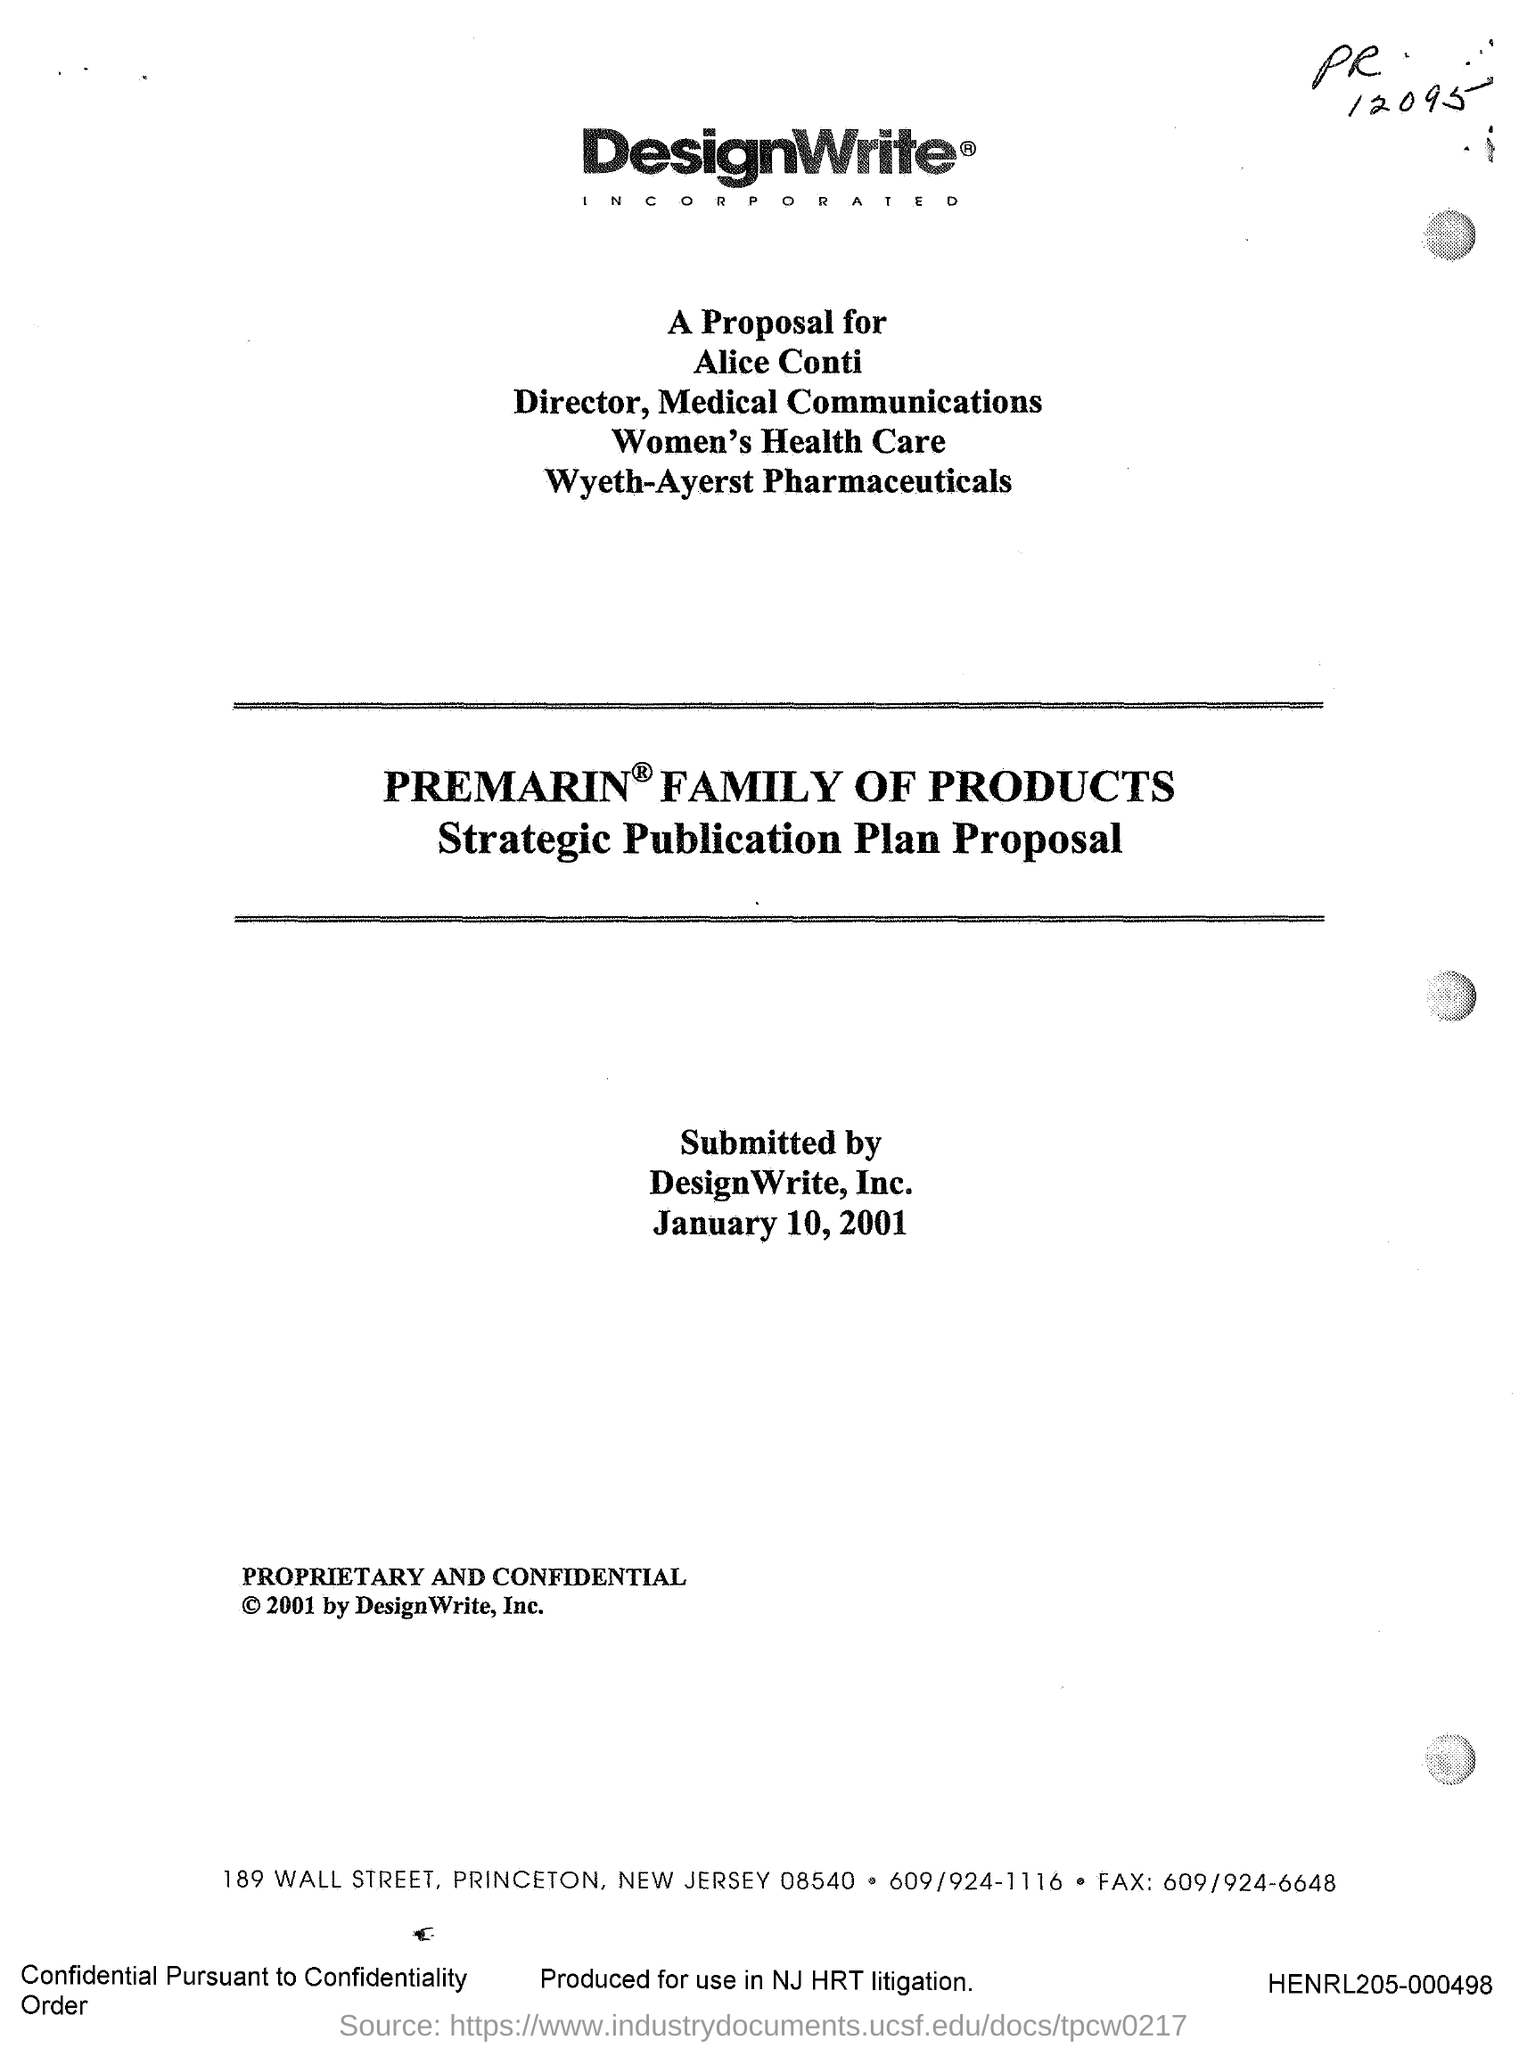Point out several critical features in this image. The submission was made on January 10, 2001. The document was produced for use in the New Jersey HRT litigation. The document number is "HENRL205-000498..". 